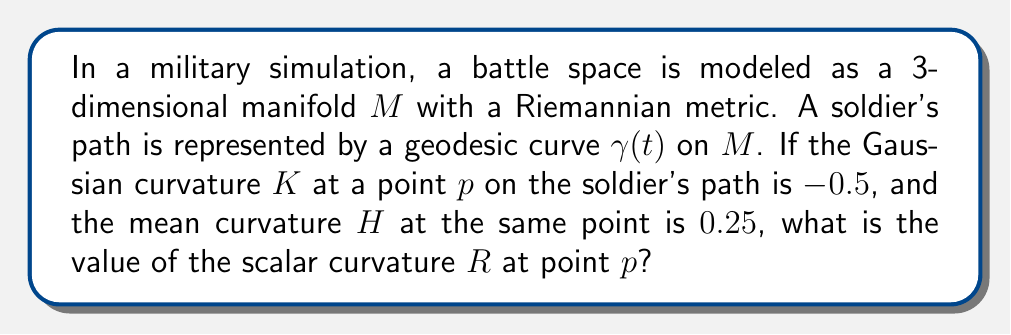Could you help me with this problem? Let's approach this step-by-step:

1) In a 3-dimensional Riemannian manifold, the scalar curvature $R$ is related to the Gaussian curvature $K$ and the mean curvature $H$ by the following formula:

   $$R = 6K - 2H^2$$

2) We are given that:
   - Gaussian curvature $K = -0.5$
   - Mean curvature $H = 0.25$

3) Let's substitute these values into the formula:

   $$R = 6(-0.5) - 2(0.25)^2$$

4) First, let's calculate $6K$:
   $$6K = 6(-0.5) = -3$$

5) Now, let's calculate $2H^2$:
   $$2H^2 = 2(0.25)^2 = 2(0.0625) = 0.125$$

6) Finally, we can subtract:
   $$R = -3 - 0.125 = -3.125$$

Therefore, the scalar curvature $R$ at point $p$ is $-3.125$.
Answer: $-3.125$ 